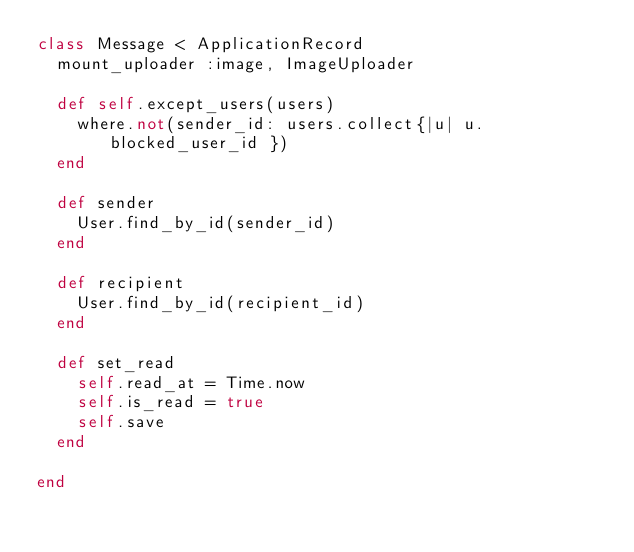<code> <loc_0><loc_0><loc_500><loc_500><_Ruby_>class Message < ApplicationRecord
  mount_uploader :image, ImageUploader

  def self.except_users(users)
    where.not(sender_id: users.collect{|u| u.blocked_user_id })
  end

  def sender
    User.find_by_id(sender_id)
  end

  def recipient
    User.find_by_id(recipient_id)
  end

  def set_read
    self.read_at = Time.now
    self.is_read = true
    self.save
  end

end
</code> 